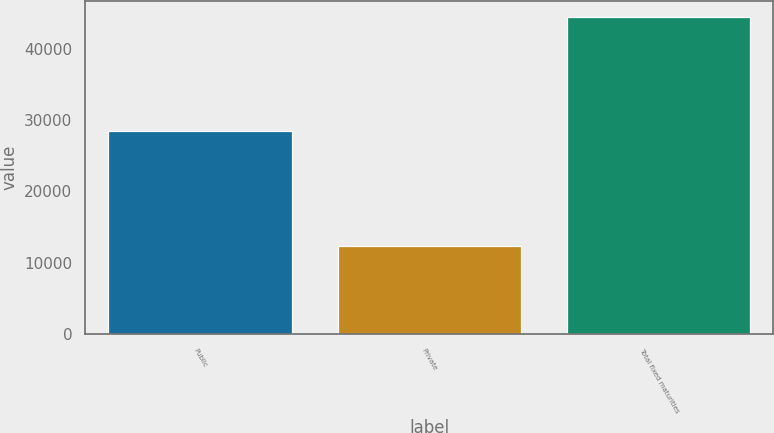<chart> <loc_0><loc_0><loc_500><loc_500><bar_chart><fcel>Public<fcel>Private<fcel>Total fixed maturities<nl><fcel>28497.9<fcel>12298.2<fcel>44491.9<nl></chart> 